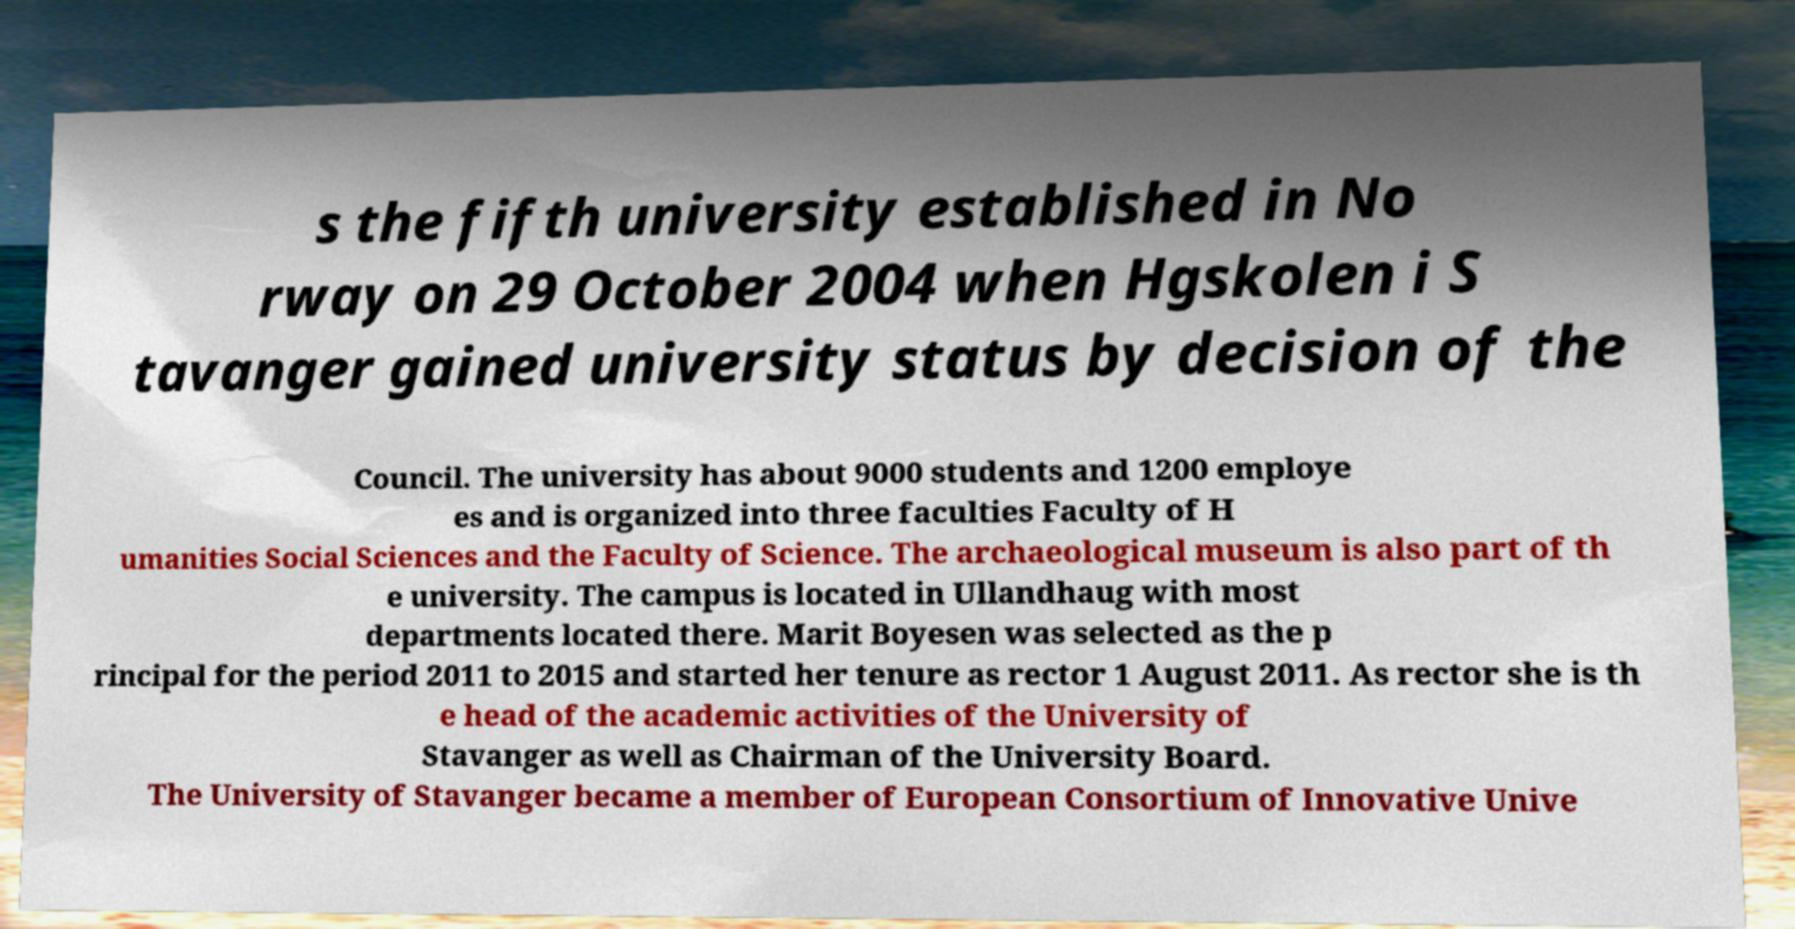I need the written content from this picture converted into text. Can you do that? s the fifth university established in No rway on 29 October 2004 when Hgskolen i S tavanger gained university status by decision of the Council. The university has about 9000 students and 1200 employe es and is organized into three faculties Faculty of H umanities Social Sciences and the Faculty of Science. The archaeological museum is also part of th e university. The campus is located in Ullandhaug with most departments located there. Marit Boyesen was selected as the p rincipal for the period 2011 to 2015 and started her tenure as rector 1 August 2011. As rector she is th e head of the academic activities of the University of Stavanger as well as Chairman of the University Board. The University of Stavanger became a member of European Consortium of Innovative Unive 